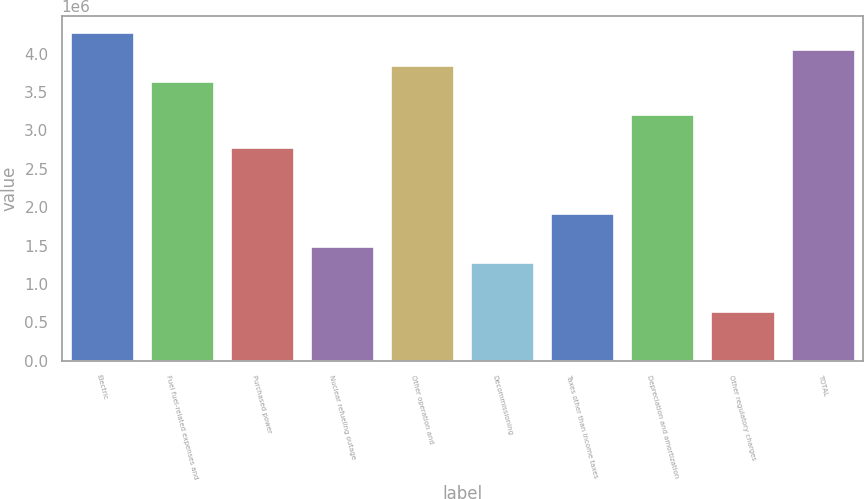Convert chart to OTSL. <chart><loc_0><loc_0><loc_500><loc_500><bar_chart><fcel>Electric<fcel>Fuel fuel-related expenses and<fcel>Purchased power<fcel>Nuclear refueling outage<fcel>Other operation and<fcel>Decommissioning<fcel>Taxes other than income taxes<fcel>Depreciation and amortization<fcel>Other regulatory charges<fcel>TOTAL<nl><fcel>4.27954e+06<fcel>3.63765e+06<fcel>2.7818e+06<fcel>1.49803e+06<fcel>3.85162e+06<fcel>1.28407e+06<fcel>1.92596e+06<fcel>3.20973e+06<fcel>642185<fcel>4.06558e+06<nl></chart> 